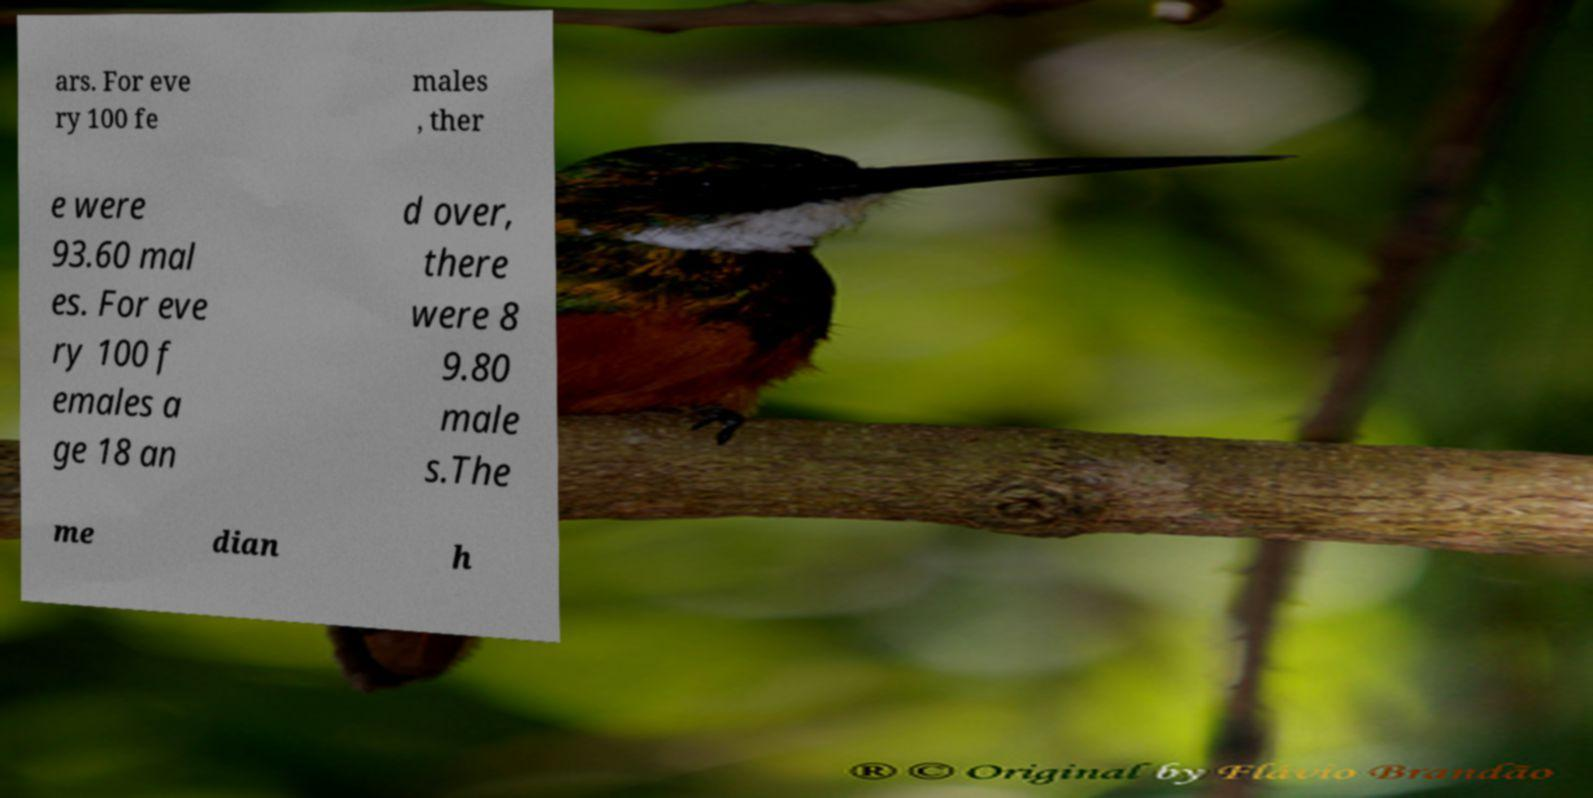Can you accurately transcribe the text from the provided image for me? ars. For eve ry 100 fe males , ther e were 93.60 mal es. For eve ry 100 f emales a ge 18 an d over, there were 8 9.80 male s.The me dian h 